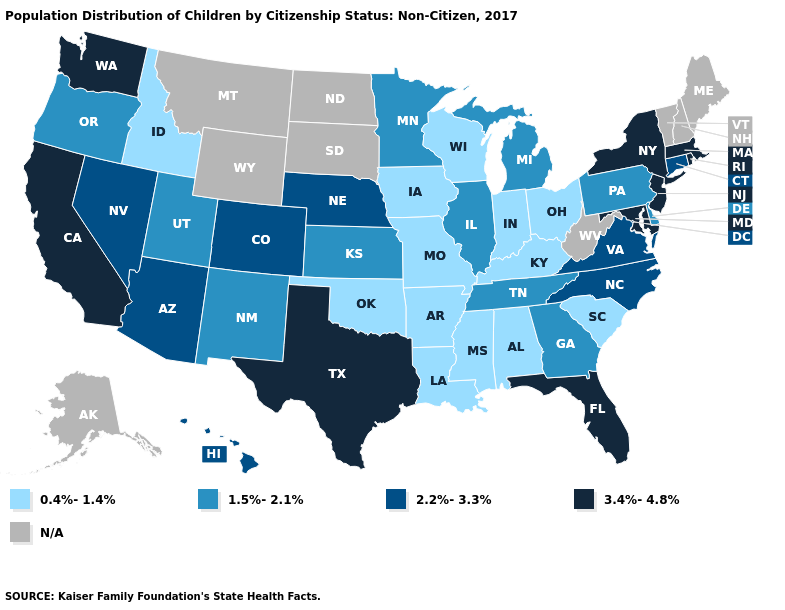Does Massachusetts have the highest value in the Northeast?
Keep it brief. Yes. Does the first symbol in the legend represent the smallest category?
Be succinct. Yes. Name the states that have a value in the range 2.2%-3.3%?
Short answer required. Arizona, Colorado, Connecticut, Hawaii, Nebraska, Nevada, North Carolina, Virginia. Which states have the lowest value in the South?
Write a very short answer. Alabama, Arkansas, Kentucky, Louisiana, Mississippi, Oklahoma, South Carolina. Name the states that have a value in the range 1.5%-2.1%?
Give a very brief answer. Delaware, Georgia, Illinois, Kansas, Michigan, Minnesota, New Mexico, Oregon, Pennsylvania, Tennessee, Utah. Name the states that have a value in the range 2.2%-3.3%?
Keep it brief. Arizona, Colorado, Connecticut, Hawaii, Nebraska, Nevada, North Carolina, Virginia. Does Idaho have the lowest value in the USA?
Concise answer only. Yes. What is the value of Kansas?
Be succinct. 1.5%-2.1%. Name the states that have a value in the range 0.4%-1.4%?
Give a very brief answer. Alabama, Arkansas, Idaho, Indiana, Iowa, Kentucky, Louisiana, Mississippi, Missouri, Ohio, Oklahoma, South Carolina, Wisconsin. What is the highest value in the USA?
Short answer required. 3.4%-4.8%. What is the value of Missouri?
Keep it brief. 0.4%-1.4%. What is the value of Alaska?
Concise answer only. N/A. What is the value of Florida?
Answer briefly. 3.4%-4.8%. What is the lowest value in the Northeast?
Concise answer only. 1.5%-2.1%. 